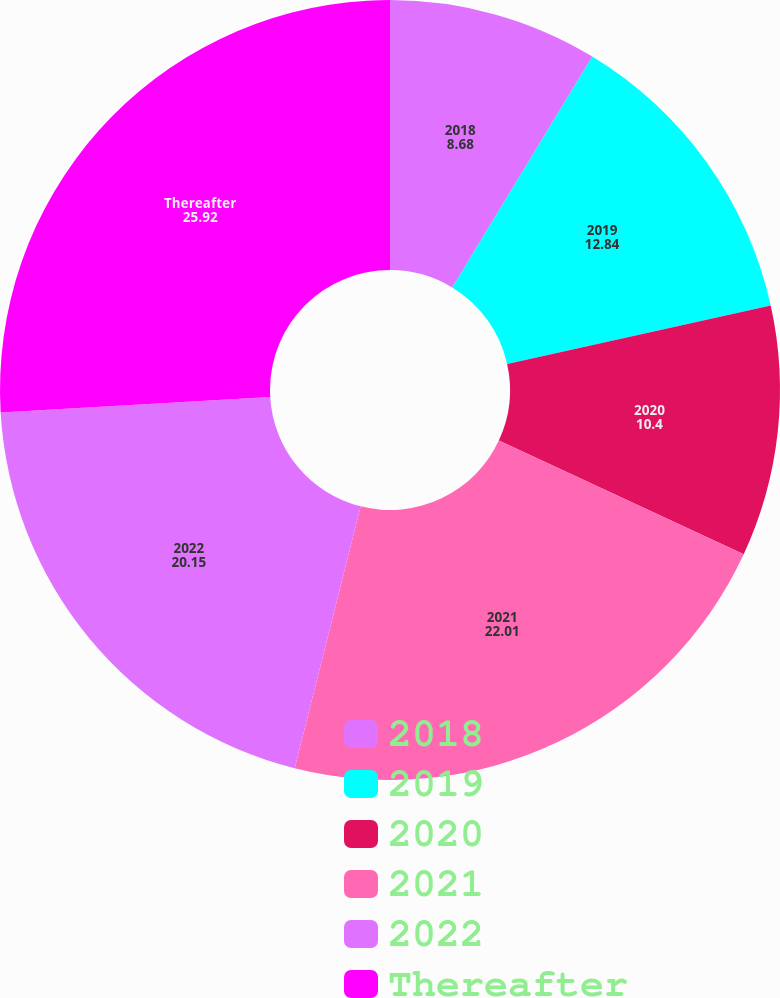<chart> <loc_0><loc_0><loc_500><loc_500><pie_chart><fcel>2018<fcel>2019<fcel>2020<fcel>2021<fcel>2022<fcel>Thereafter<nl><fcel>8.68%<fcel>12.84%<fcel>10.4%<fcel>22.01%<fcel>20.15%<fcel>25.92%<nl></chart> 